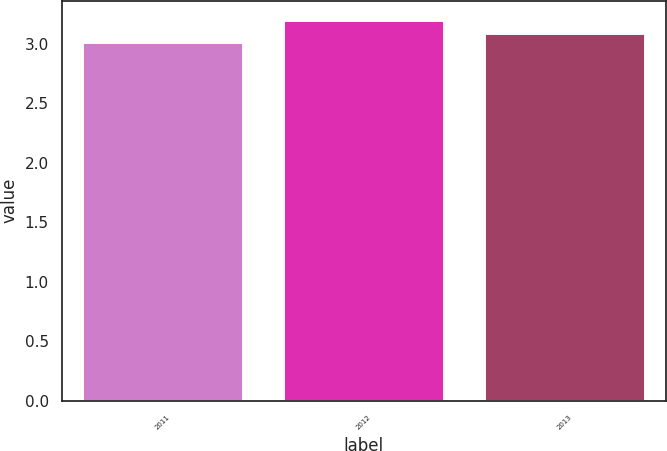<chart> <loc_0><loc_0><loc_500><loc_500><bar_chart><fcel>2011<fcel>2012<fcel>2013<nl><fcel>3.01<fcel>3.2<fcel>3.09<nl></chart> 